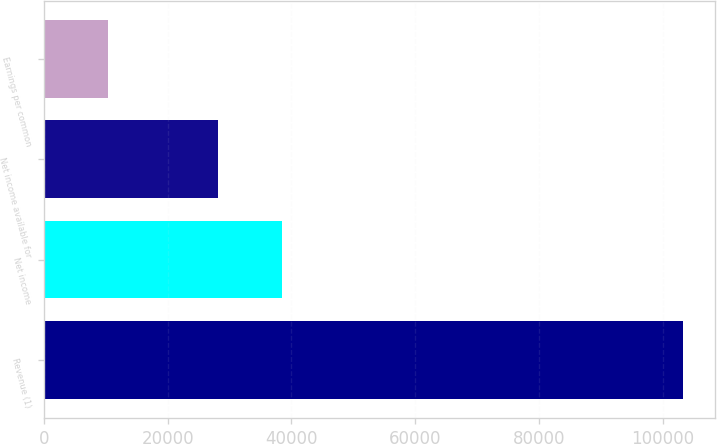<chart> <loc_0><loc_0><loc_500><loc_500><bar_chart><fcel>Revenue (1)<fcel>Net income<fcel>Net income available for<fcel>Earnings per common<nl><fcel>103373<fcel>38499.2<fcel>28162<fcel>10337.8<nl></chart> 